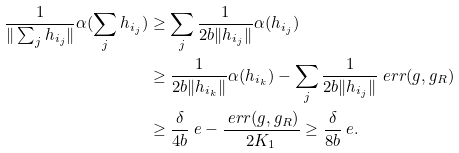<formula> <loc_0><loc_0><loc_500><loc_500>\frac { 1 } { \| \sum _ { j } h _ { i _ { j } } \| } \alpha ( \sum _ { j } h _ { i _ { j } } ) & \geq \sum _ { j } \frac { 1 } { 2 b \| h _ { i _ { j } } \| } \alpha ( h _ { i _ { j } } ) \\ & \geq \frac { 1 } { 2 b \| h _ { i _ { k } } \| } \alpha ( h _ { i _ { k } } ) - \sum _ { j } \frac { 1 } { 2 b \| h _ { i _ { j } } \| } \ e r r ( g , g _ { R } ) \\ & \geq \frac { \delta } { 4 b } \ e - \frac { \ e r r ( g , g _ { R } ) } { 2 K _ { 1 } } \geq \frac { \delta } { 8 b } \ e .</formula> 